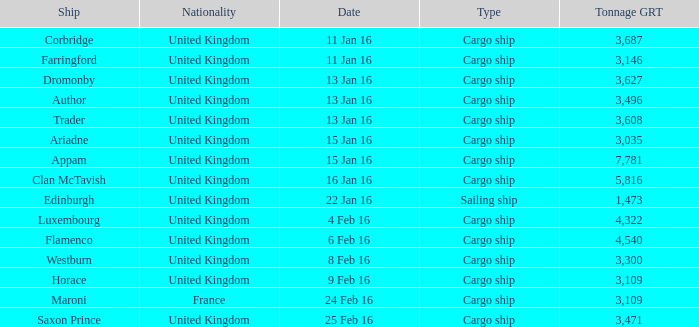What is the most tonnage grt of any ship sunk or captured on 16 jan 16? 5816.0. Would you be able to parse every entry in this table? {'header': ['Ship', 'Nationality', 'Date', 'Type', 'Tonnage GRT'], 'rows': [['Corbridge', 'United Kingdom', '11 Jan 16', 'Cargo ship', '3,687'], ['Farringford', 'United Kingdom', '11 Jan 16', 'Cargo ship', '3,146'], ['Dromonby', 'United Kingdom', '13 Jan 16', 'Cargo ship', '3,627'], ['Author', 'United Kingdom', '13 Jan 16', 'Cargo ship', '3,496'], ['Trader', 'United Kingdom', '13 Jan 16', 'Cargo ship', '3,608'], ['Ariadne', 'United Kingdom', '15 Jan 16', 'Cargo ship', '3,035'], ['Appam', 'United Kingdom', '15 Jan 16', 'Cargo ship', '7,781'], ['Clan McTavish', 'United Kingdom', '16 Jan 16', 'Cargo ship', '5,816'], ['Edinburgh', 'United Kingdom', '22 Jan 16', 'Sailing ship', '1,473'], ['Luxembourg', 'United Kingdom', '4 Feb 16', 'Cargo ship', '4,322'], ['Flamenco', 'United Kingdom', '6 Feb 16', 'Cargo ship', '4,540'], ['Westburn', 'United Kingdom', '8 Feb 16', 'Cargo ship', '3,300'], ['Horace', 'United Kingdom', '9 Feb 16', 'Cargo ship', '3,109'], ['Maroni', 'France', '24 Feb 16', 'Cargo ship', '3,109'], ['Saxon Prince', 'United Kingdom', '25 Feb 16', 'Cargo ship', '3,471']]} 